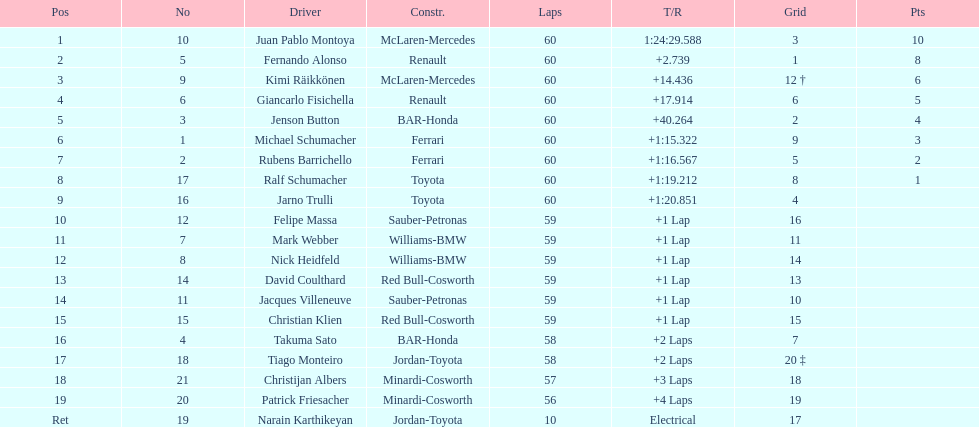Would you be able to parse every entry in this table? {'header': ['Pos', 'No', 'Driver', 'Constr.', 'Laps', 'T/R', 'Grid', 'Pts'], 'rows': [['1', '10', 'Juan Pablo Montoya', 'McLaren-Mercedes', '60', '1:24:29.588', '3', '10'], ['2', '5', 'Fernando Alonso', 'Renault', '60', '+2.739', '1', '8'], ['3', '9', 'Kimi Räikkönen', 'McLaren-Mercedes', '60', '+14.436', '12 †', '6'], ['4', '6', 'Giancarlo Fisichella', 'Renault', '60', '+17.914', '6', '5'], ['5', '3', 'Jenson Button', 'BAR-Honda', '60', '+40.264', '2', '4'], ['6', '1', 'Michael Schumacher', 'Ferrari', '60', '+1:15.322', '9', '3'], ['7', '2', 'Rubens Barrichello', 'Ferrari', '60', '+1:16.567', '5', '2'], ['8', '17', 'Ralf Schumacher', 'Toyota', '60', '+1:19.212', '8', '1'], ['9', '16', 'Jarno Trulli', 'Toyota', '60', '+1:20.851', '4', ''], ['10', '12', 'Felipe Massa', 'Sauber-Petronas', '59', '+1 Lap', '16', ''], ['11', '7', 'Mark Webber', 'Williams-BMW', '59', '+1 Lap', '11', ''], ['12', '8', 'Nick Heidfeld', 'Williams-BMW', '59', '+1 Lap', '14', ''], ['13', '14', 'David Coulthard', 'Red Bull-Cosworth', '59', '+1 Lap', '13', ''], ['14', '11', 'Jacques Villeneuve', 'Sauber-Petronas', '59', '+1 Lap', '10', ''], ['15', '15', 'Christian Klien', 'Red Bull-Cosworth', '59', '+1 Lap', '15', ''], ['16', '4', 'Takuma Sato', 'BAR-Honda', '58', '+2 Laps', '7', ''], ['17', '18', 'Tiago Monteiro', 'Jordan-Toyota', '58', '+2 Laps', '20 ‡', ''], ['18', '21', 'Christijan Albers', 'Minardi-Cosworth', '57', '+3 Laps', '18', ''], ['19', '20', 'Patrick Friesacher', 'Minardi-Cosworth', '56', '+4 Laps', '19', ''], ['Ret', '19', 'Narain Karthikeyan', 'Jordan-Toyota', '10', 'Electrical', '17', '']]} How many drivers received points from the race? 8. 